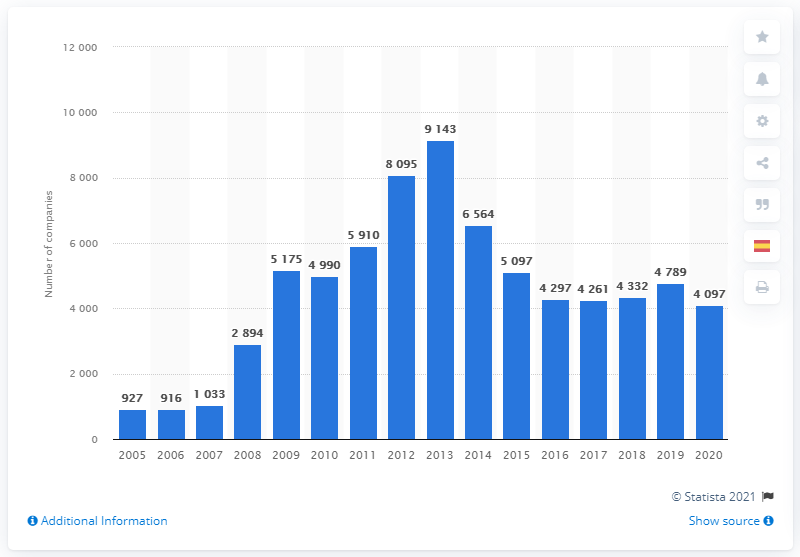When did the number of companies declared bankrupt start decreasing? According to the data shown in the image, the number of companies declared bankrupt started to decrease after peaking in 2009. The graph displays a notable decline from 2010 onwards, with the first significant drop occurring from 9,143 bankruptcies in 2009 to 8,095 in 2010. 